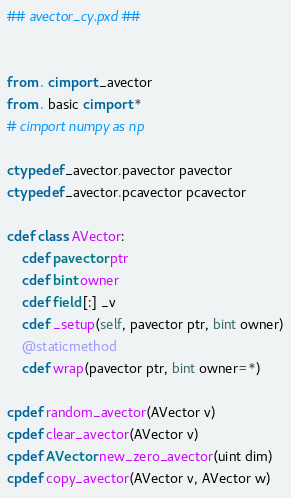Convert code to text. <code><loc_0><loc_0><loc_500><loc_500><_Cython_>## avector_cy.pxd ##


from . cimport _avector
from . basic cimport *
# cimport numpy as np

ctypedef _avector.pavector pavector
ctypedef _avector.pcavector pcavector

cdef class AVector:
    cdef pavector ptr
    cdef bint owner
    cdef field [:] _v
    cdef _setup(self, pavector ptr, bint owner)
    @staticmethod
    cdef wrap(pavector ptr, bint owner=*)

cpdef random_avector(AVector v)
cpdef clear_avector(AVector v)
cpdef AVector new_zero_avector(uint dim)
cpdef copy_avector(AVector v, AVector w)</code> 